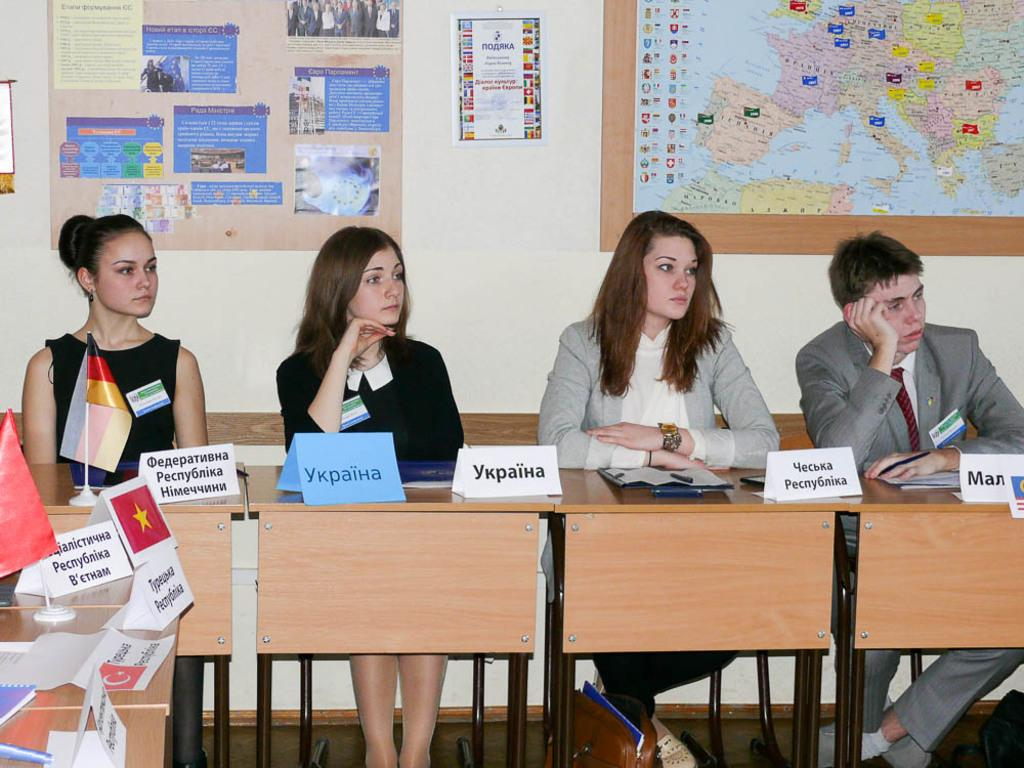How many people are seated on the bench in the image? There are four people seated on a bench in the image. What is on the table in the image? There is a flag on a table in the image. What can be seen on the wall in the image? There is a poster and a map on the wall in the image. What type of dirt is visible on the poster in the image? There is no dirt visible on the poster in the image, as the poster is not described as being dirty. How many parents are present in the image? The provided facts do not mention any parents in the image, so we cannot determine the number of parents present. 